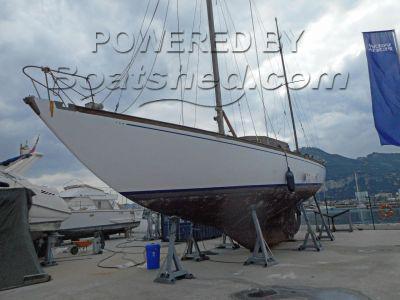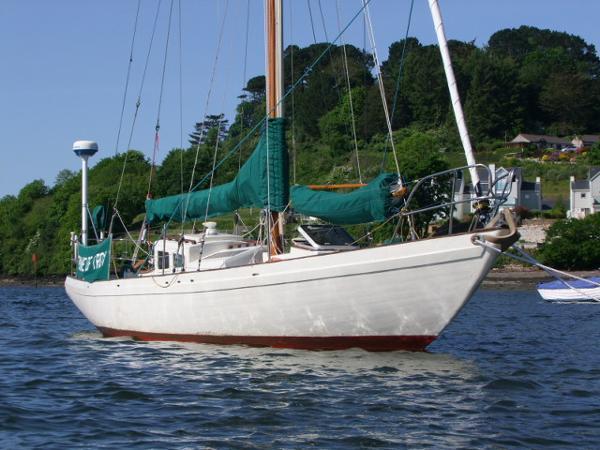The first image is the image on the left, the second image is the image on the right. Analyze the images presented: Is the assertion "The left and right image contains the same number of sailboats." valid? Answer yes or no. Yes. The first image is the image on the left, the second image is the image on the right. For the images displayed, is the sentence "A boat in the right image is out of the water." factually correct? Answer yes or no. No. 